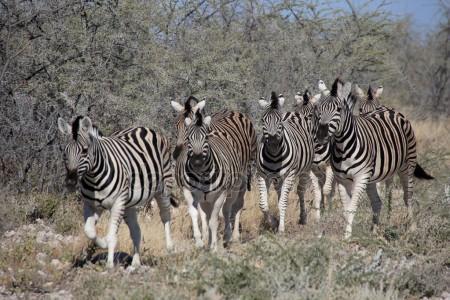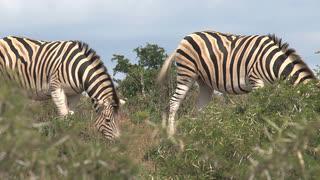The first image is the image on the left, the second image is the image on the right. For the images displayed, is the sentence "The left image features a row of no more than seven zebras with bodies mostly parallel to one another and heads raised, and the right image includes zebras with lowered heads." factually correct? Answer yes or no. Yes. The first image is the image on the left, the second image is the image on the right. Analyze the images presented: Is the assertion "The right image contains exactly two zebras." valid? Answer yes or no. Yes. 